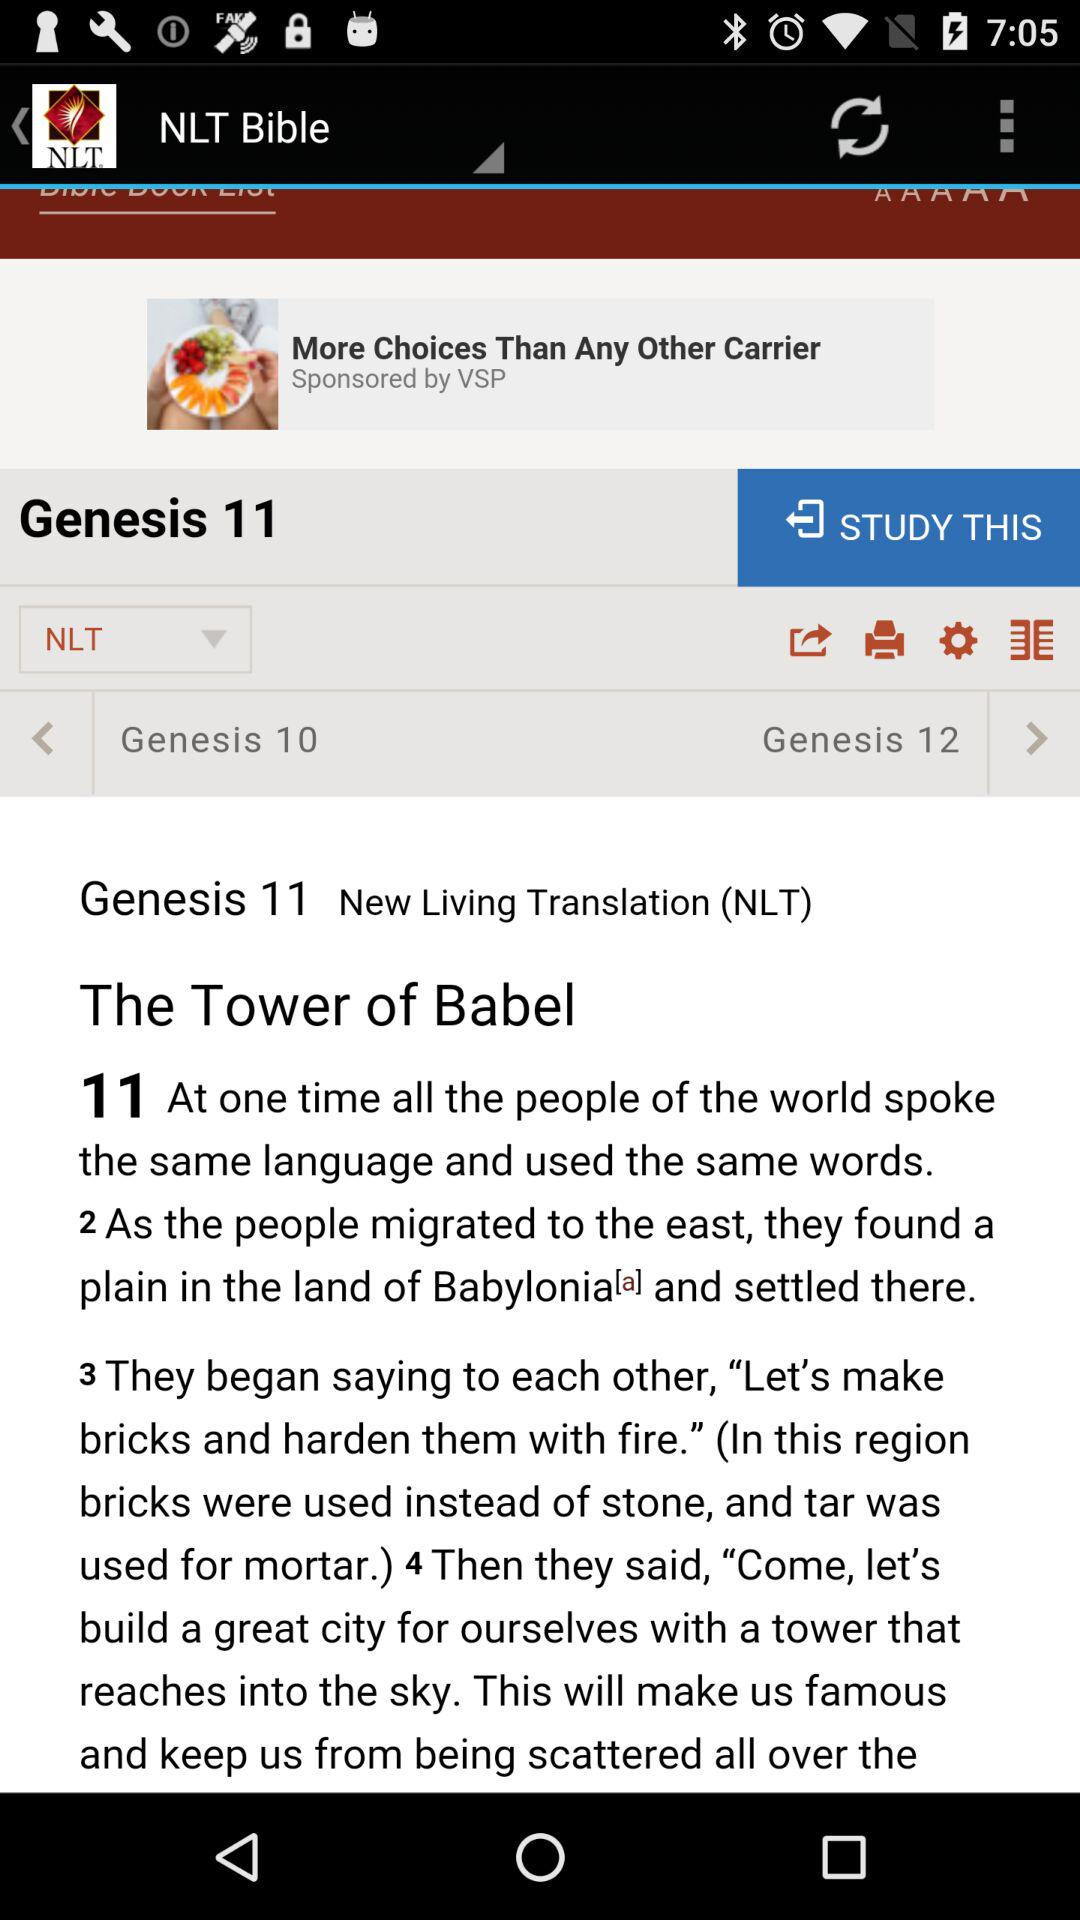What is the full form of the NLT? The full form of the NLT is New Living Translation. 